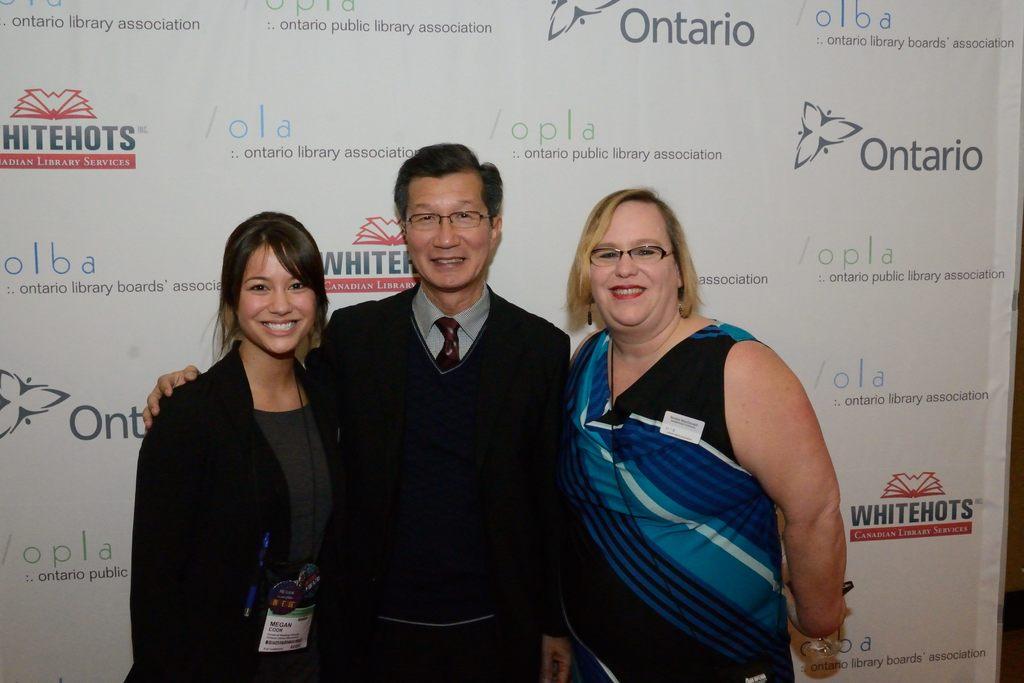What province is mentioned on the wall behind the people?
Make the answer very short. Ontario. 